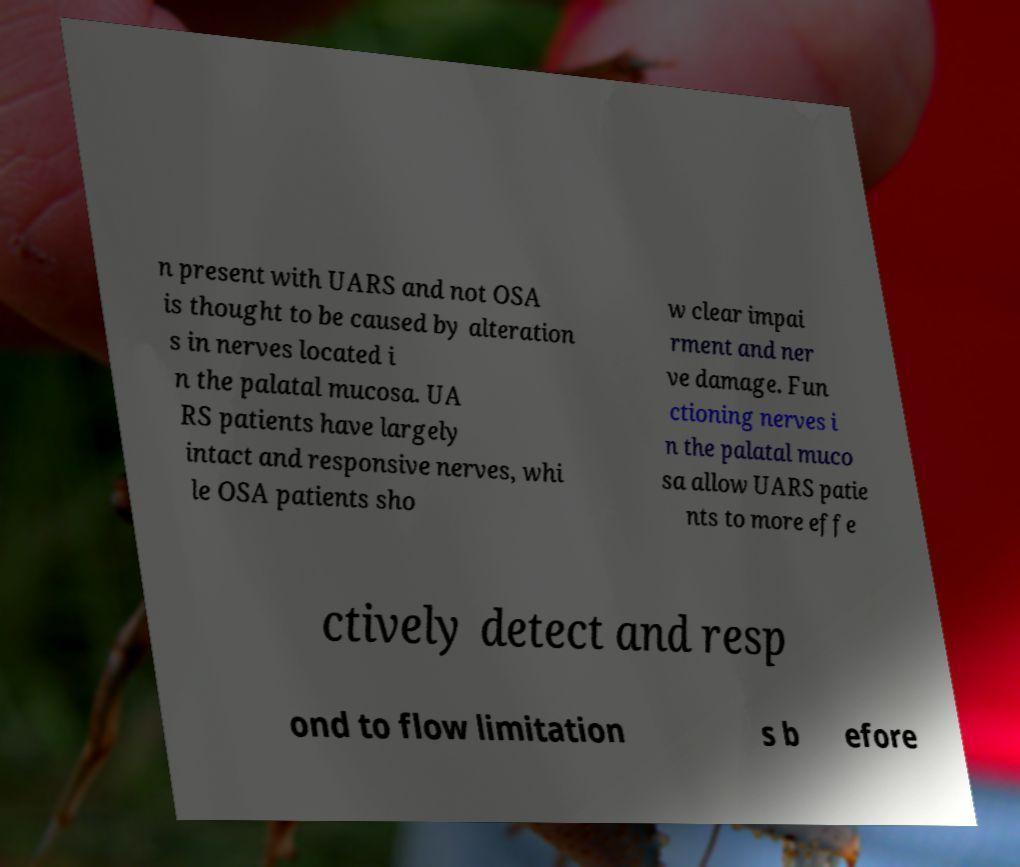Could you assist in decoding the text presented in this image and type it out clearly? n present with UARS and not OSA is thought to be caused by alteration s in nerves located i n the palatal mucosa. UA RS patients have largely intact and responsive nerves, whi le OSA patients sho w clear impai rment and ner ve damage. Fun ctioning nerves i n the palatal muco sa allow UARS patie nts to more effe ctively detect and resp ond to flow limitation s b efore 